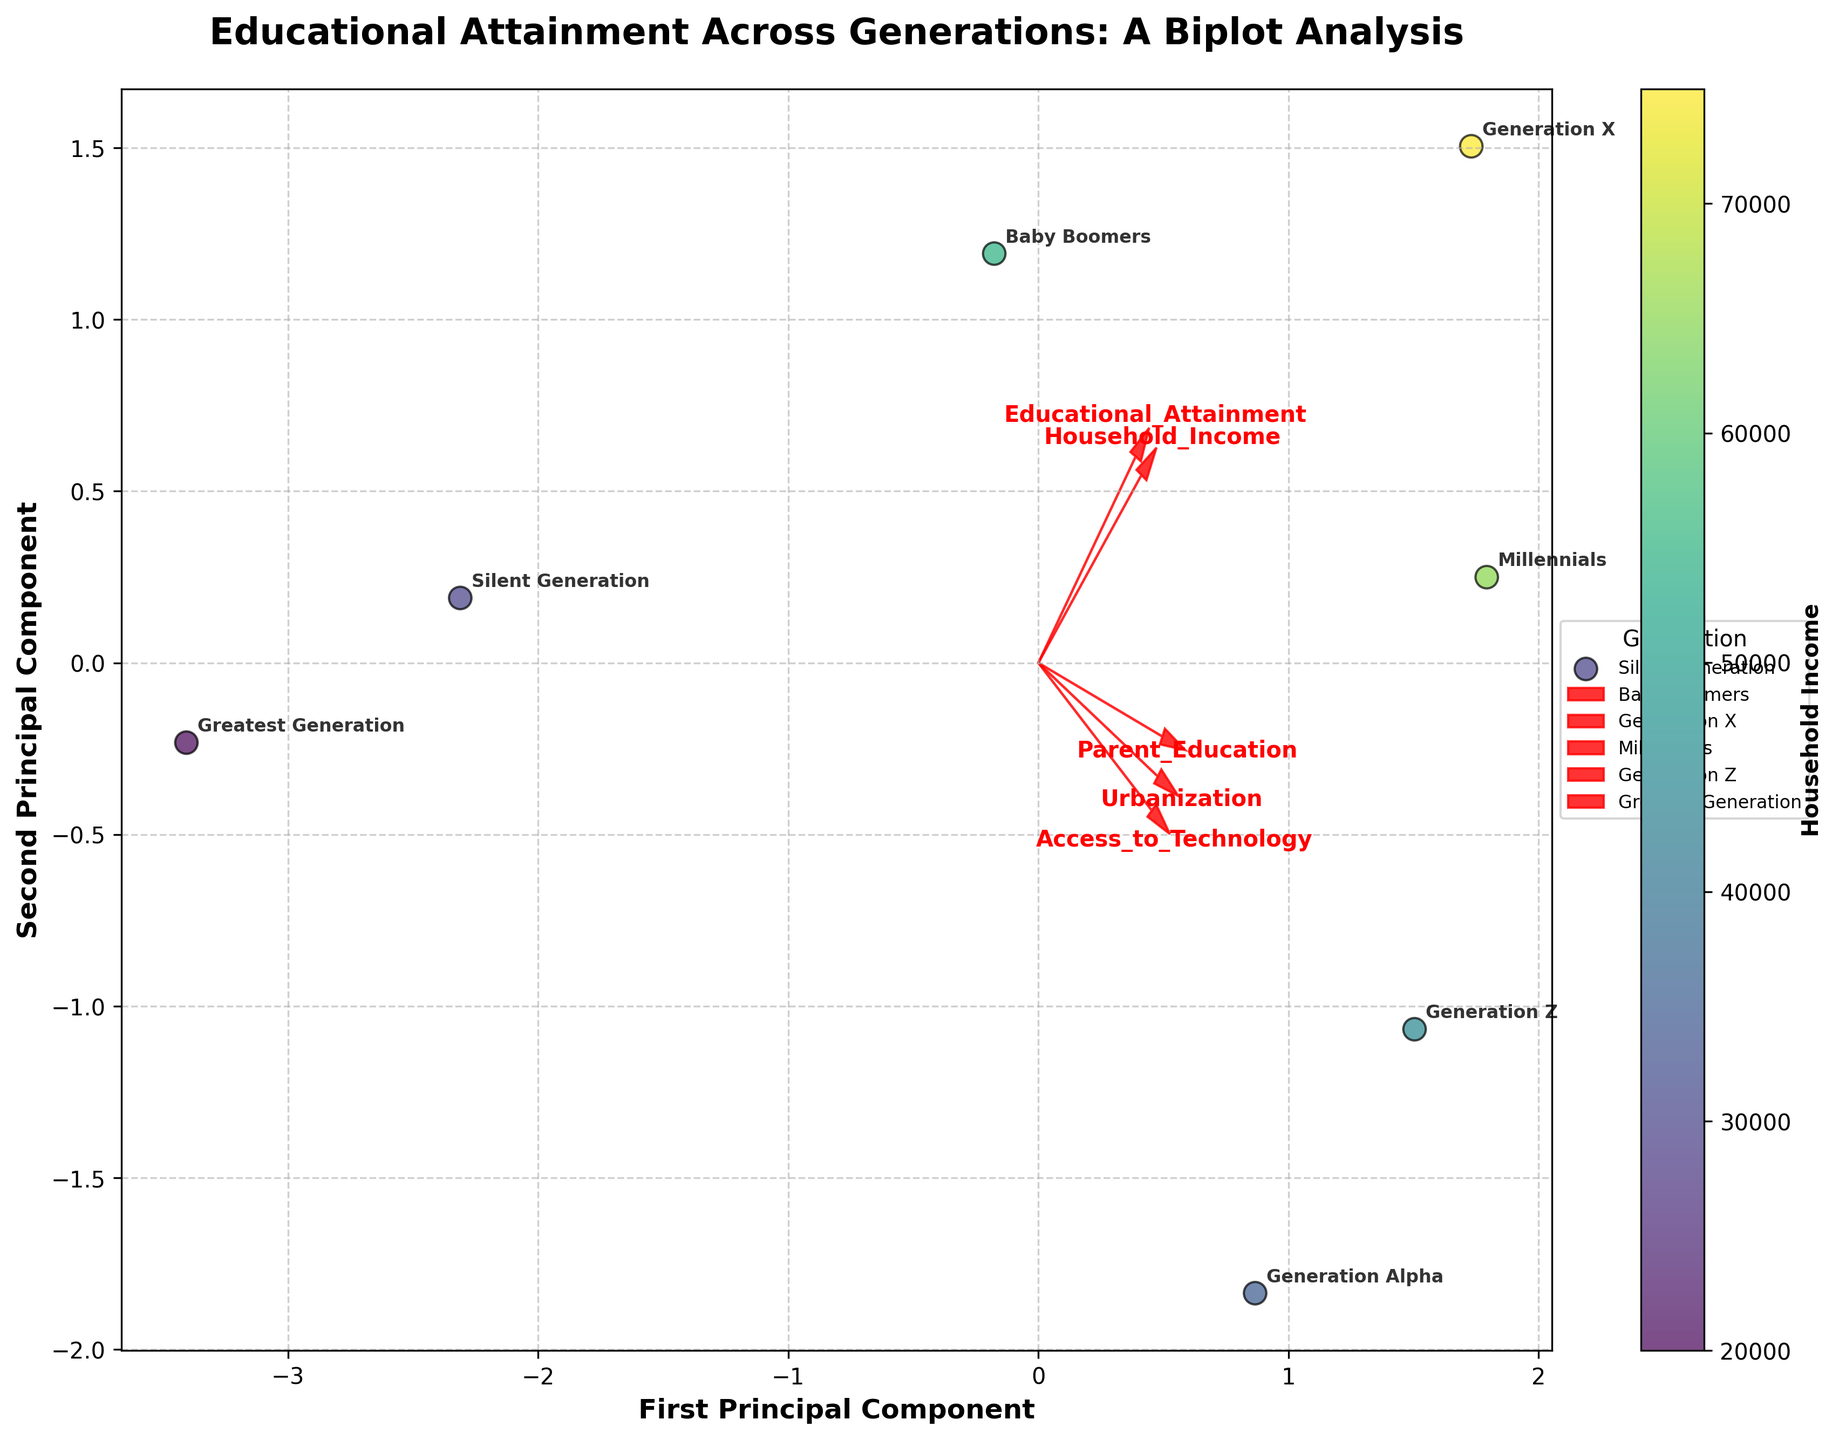Where is the Silent Generation positioned on the biplot? The Silent Generation is represented by a point with an associated label. Locate the data point labeled "Silent Generation" on the biplot to identify its position.
Answer: The position of the Silent Generation would be wherever its point is plotted on the biplot Which generation has the highest label indicating their Household Income? The generation with the highest Household Income is represented by the data point with the deepest shade of the color palette. The colorbar assist in determining this.
Answer: Generation X How do educational attainment and household income correlate according to the biplot? Observe the direction and length of the arrows for Educational_Attainment and Household_Income. If they point in the same or nearly the same direction, they are positively correlated; the correlation is stronger if they are closely aligned and longer.
Answer: Positively correlated Which features have vectors pointing in opposite directions on the biplot? Identify vector pairs that point in roughly opposite directions, implying a negative correlation between those features. Look for pairs facing away from each other at nearly 180 degrees.
Answer: Parent_Education and Urbanization Which generation seems to have the most advanced Access to Technology? Check for the data point associated with the highest value on the Access_to_Technology axis. Higher values tend to be positioned further in the direction of the Access_to_Technology vector.
Answer: Generation Alpha How does the Greatest Generation compare to Generation Z in terms of Parent Education? Observe the positioning of both generations relative to the Parent_Education vector. The direction closer to the vector represents higher values.
Answer: Greatest Generation has lower Parent Education What does the length of the Access_to_Technology arrow suggest about its variance in the data? Longer arrows in a PCA biplot indicate higher variance accounted for by that feature in the dataset. Measure the arrow's length from the origin to the tip.
Answer: High variance Which generation is closest to the centroid of the biplot? The centroid of the biplot is the origin (0, 0). Find the data point representing the generation closest to this central position.
Answer: Generation Alpha How do Urbanization and Educational_Attainment relate to each other? Look at the arrows for Urbanization and Educational_Attainment to determine their relationship. If they align closely, they show a strong positive correlation.
Answer: Positively correlated 